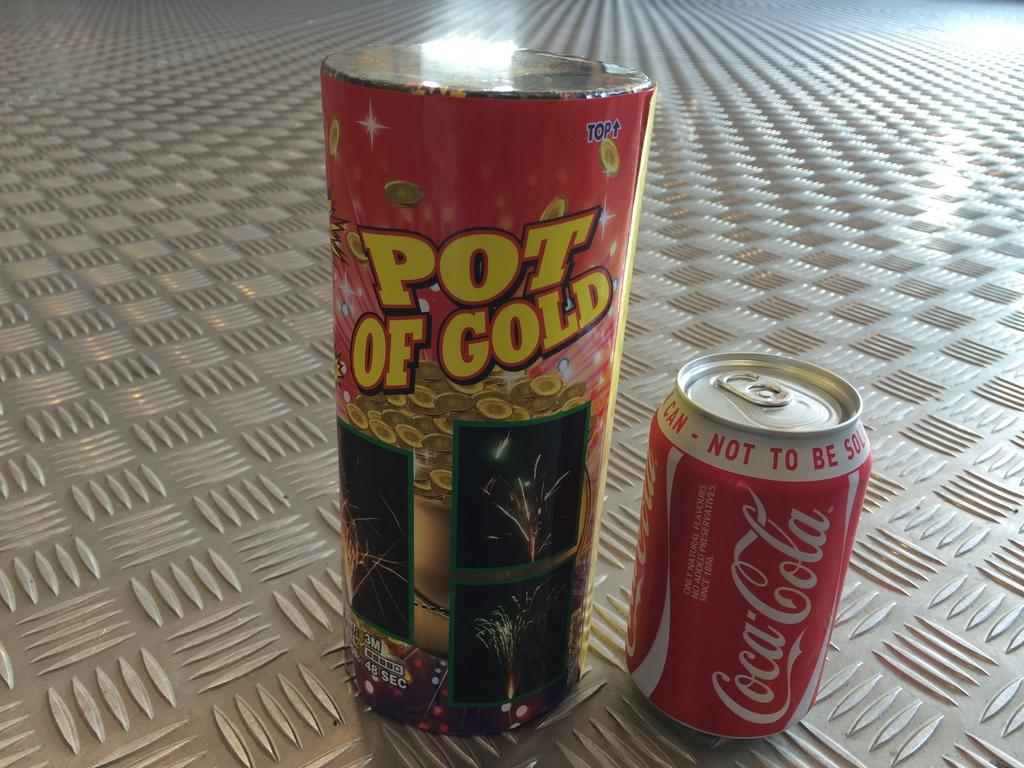<image>
Present a compact description of the photo's key features. the words Pot of Gold are on a can next to a coke can 